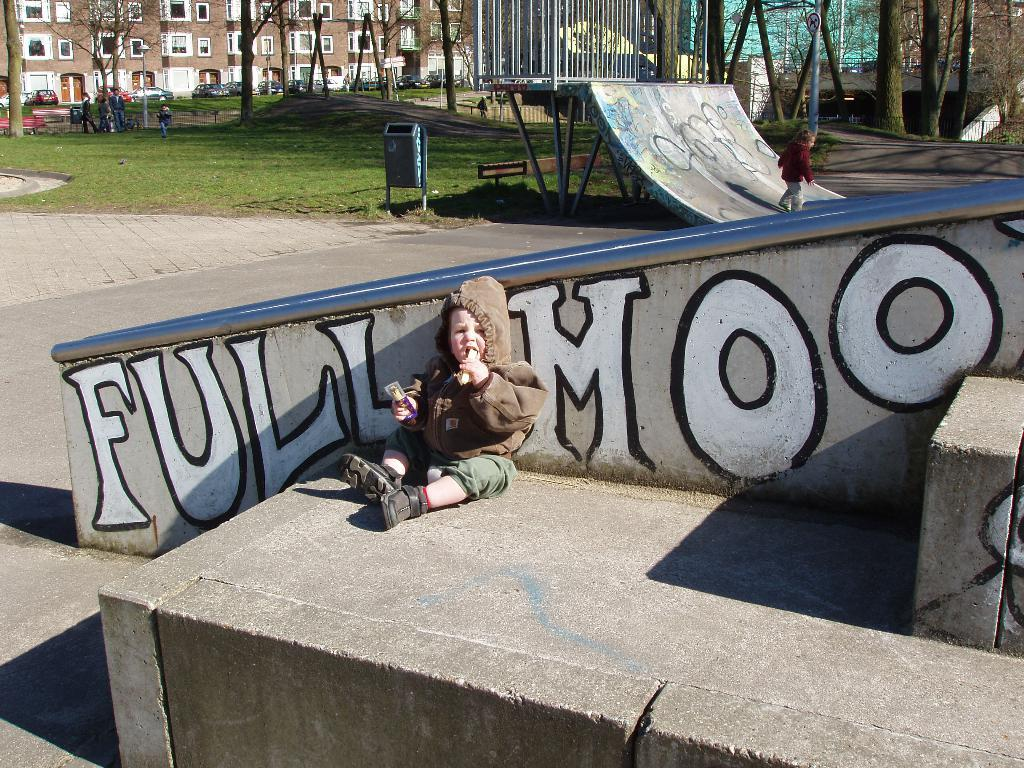What is the main subject of the image? The main subject of the image is a kid sitting at the wall in the center. What activity is happening in the background? In the background, a kid is skating. What objects can be seen in the background? In the background, there is a dustbin, persons, grass, trees, a building, a road, and a sign board. What type of flower is the kid holding in the image? There is no flower present in the image. Can you see any branches in the image? There are no branches visible in the image. 